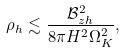Convert formula to latex. <formula><loc_0><loc_0><loc_500><loc_500>\rho _ { h } \lesssim \frac { \mathcal { B } _ { z h } ^ { 2 } } { 8 \pi H ^ { 2 } \Omega _ { K } ^ { 2 } } ,</formula> 